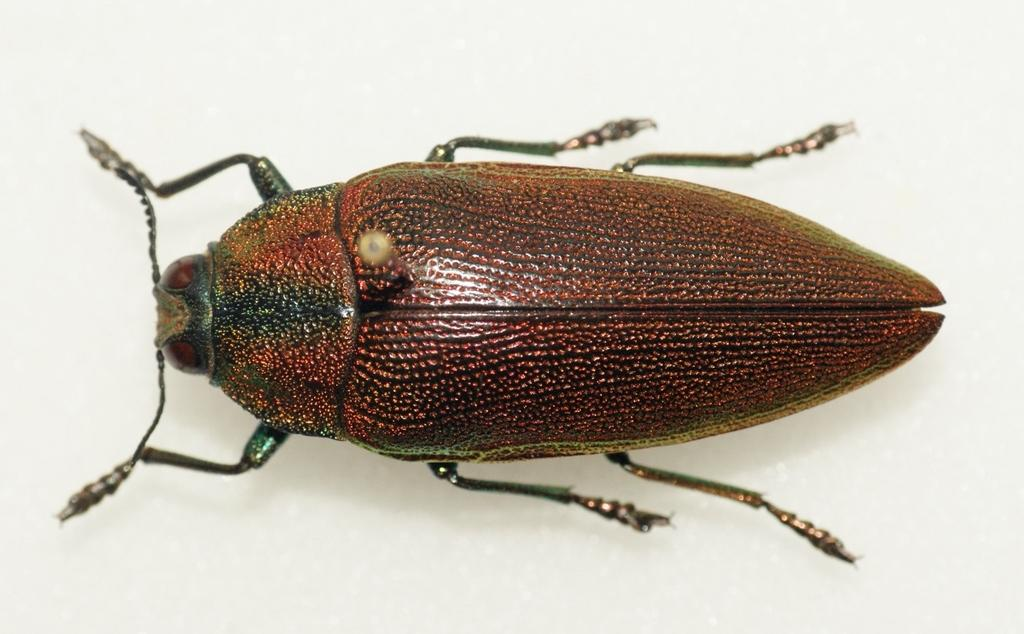What is the main subject of the image? The main subject of the image is a cockroach. Can you describe the appearance of the cockroach? The cockroach is brown in color. What type of meal is being prepared in the image? There is no meal preparation visible in the image; it features a brown cockroach. What type of jelly can be seen growing on the bushes in the image? There are no bushes or jelly present in the image; it features a brown cockroach. 